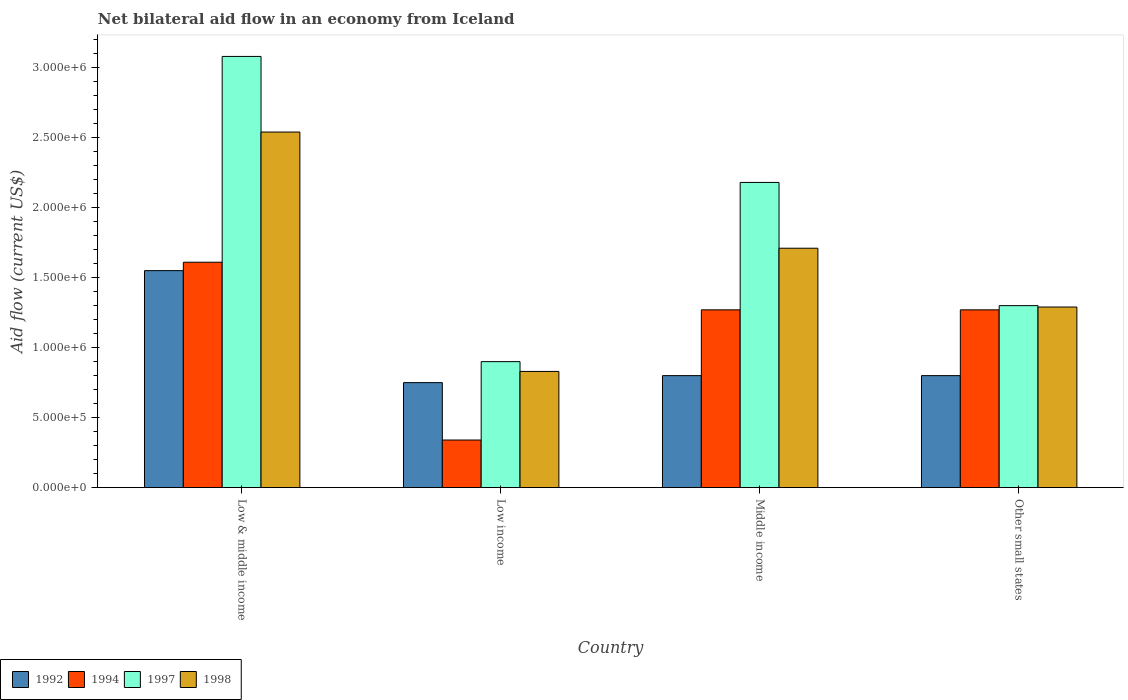How many different coloured bars are there?
Ensure brevity in your answer.  4. How many groups of bars are there?
Provide a short and direct response. 4. Are the number of bars per tick equal to the number of legend labels?
Provide a succinct answer. Yes. How many bars are there on the 1st tick from the left?
Keep it short and to the point. 4. What is the label of the 4th group of bars from the left?
Keep it short and to the point. Other small states. In how many cases, is the number of bars for a given country not equal to the number of legend labels?
Keep it short and to the point. 0. What is the net bilateral aid flow in 1998 in Low & middle income?
Give a very brief answer. 2.54e+06. Across all countries, what is the maximum net bilateral aid flow in 1994?
Offer a very short reply. 1.61e+06. Across all countries, what is the minimum net bilateral aid flow in 1997?
Offer a terse response. 9.00e+05. In which country was the net bilateral aid flow in 1997 maximum?
Provide a succinct answer. Low & middle income. In which country was the net bilateral aid flow in 1997 minimum?
Your answer should be very brief. Low income. What is the total net bilateral aid flow in 1997 in the graph?
Your answer should be very brief. 7.46e+06. What is the difference between the net bilateral aid flow in 1994 in Low & middle income and the net bilateral aid flow in 1997 in Middle income?
Offer a terse response. -5.70e+05. What is the average net bilateral aid flow in 1997 per country?
Your response must be concise. 1.86e+06. What is the difference between the net bilateral aid flow of/in 1994 and net bilateral aid flow of/in 1992 in Low income?
Your response must be concise. -4.10e+05. In how many countries, is the net bilateral aid flow in 1994 greater than 1000000 US$?
Your answer should be very brief. 3. What is the ratio of the net bilateral aid flow in 1997 in Low & middle income to that in Other small states?
Give a very brief answer. 2.37. What is the difference between the highest and the second highest net bilateral aid flow in 1997?
Offer a very short reply. 1.78e+06. What is the difference between the highest and the lowest net bilateral aid flow in 1997?
Offer a terse response. 2.18e+06. In how many countries, is the net bilateral aid flow in 1997 greater than the average net bilateral aid flow in 1997 taken over all countries?
Offer a terse response. 2. Is the sum of the net bilateral aid flow in 1997 in Low & middle income and Low income greater than the maximum net bilateral aid flow in 1992 across all countries?
Your answer should be very brief. Yes. Is it the case that in every country, the sum of the net bilateral aid flow in 1992 and net bilateral aid flow in 1994 is greater than the sum of net bilateral aid flow in 1997 and net bilateral aid flow in 1998?
Make the answer very short. No. What does the 4th bar from the left in Middle income represents?
Ensure brevity in your answer.  1998. Is it the case that in every country, the sum of the net bilateral aid flow in 1997 and net bilateral aid flow in 1992 is greater than the net bilateral aid flow in 1998?
Make the answer very short. Yes. What is the difference between two consecutive major ticks on the Y-axis?
Give a very brief answer. 5.00e+05. How are the legend labels stacked?
Make the answer very short. Horizontal. What is the title of the graph?
Keep it short and to the point. Net bilateral aid flow in an economy from Iceland. What is the label or title of the X-axis?
Provide a succinct answer. Country. What is the Aid flow (current US$) of 1992 in Low & middle income?
Give a very brief answer. 1.55e+06. What is the Aid flow (current US$) in 1994 in Low & middle income?
Offer a terse response. 1.61e+06. What is the Aid flow (current US$) in 1997 in Low & middle income?
Make the answer very short. 3.08e+06. What is the Aid flow (current US$) in 1998 in Low & middle income?
Your answer should be very brief. 2.54e+06. What is the Aid flow (current US$) of 1992 in Low income?
Keep it short and to the point. 7.50e+05. What is the Aid flow (current US$) of 1998 in Low income?
Provide a short and direct response. 8.30e+05. What is the Aid flow (current US$) of 1994 in Middle income?
Offer a terse response. 1.27e+06. What is the Aid flow (current US$) of 1997 in Middle income?
Your answer should be compact. 2.18e+06. What is the Aid flow (current US$) in 1998 in Middle income?
Provide a short and direct response. 1.71e+06. What is the Aid flow (current US$) of 1992 in Other small states?
Keep it short and to the point. 8.00e+05. What is the Aid flow (current US$) in 1994 in Other small states?
Offer a terse response. 1.27e+06. What is the Aid flow (current US$) in 1997 in Other small states?
Offer a very short reply. 1.30e+06. What is the Aid flow (current US$) of 1998 in Other small states?
Make the answer very short. 1.29e+06. Across all countries, what is the maximum Aid flow (current US$) in 1992?
Make the answer very short. 1.55e+06. Across all countries, what is the maximum Aid flow (current US$) of 1994?
Ensure brevity in your answer.  1.61e+06. Across all countries, what is the maximum Aid flow (current US$) in 1997?
Keep it short and to the point. 3.08e+06. Across all countries, what is the maximum Aid flow (current US$) in 1998?
Your answer should be very brief. 2.54e+06. Across all countries, what is the minimum Aid flow (current US$) in 1992?
Offer a terse response. 7.50e+05. Across all countries, what is the minimum Aid flow (current US$) in 1994?
Provide a short and direct response. 3.40e+05. Across all countries, what is the minimum Aid flow (current US$) in 1998?
Provide a succinct answer. 8.30e+05. What is the total Aid flow (current US$) in 1992 in the graph?
Ensure brevity in your answer.  3.90e+06. What is the total Aid flow (current US$) in 1994 in the graph?
Your answer should be very brief. 4.49e+06. What is the total Aid flow (current US$) in 1997 in the graph?
Your answer should be very brief. 7.46e+06. What is the total Aid flow (current US$) of 1998 in the graph?
Make the answer very short. 6.37e+06. What is the difference between the Aid flow (current US$) in 1992 in Low & middle income and that in Low income?
Keep it short and to the point. 8.00e+05. What is the difference between the Aid flow (current US$) in 1994 in Low & middle income and that in Low income?
Your answer should be compact. 1.27e+06. What is the difference between the Aid flow (current US$) in 1997 in Low & middle income and that in Low income?
Make the answer very short. 2.18e+06. What is the difference between the Aid flow (current US$) in 1998 in Low & middle income and that in Low income?
Ensure brevity in your answer.  1.71e+06. What is the difference between the Aid flow (current US$) of 1992 in Low & middle income and that in Middle income?
Your response must be concise. 7.50e+05. What is the difference between the Aid flow (current US$) in 1997 in Low & middle income and that in Middle income?
Ensure brevity in your answer.  9.00e+05. What is the difference between the Aid flow (current US$) in 1998 in Low & middle income and that in Middle income?
Give a very brief answer. 8.30e+05. What is the difference between the Aid flow (current US$) of 1992 in Low & middle income and that in Other small states?
Offer a terse response. 7.50e+05. What is the difference between the Aid flow (current US$) in 1994 in Low & middle income and that in Other small states?
Ensure brevity in your answer.  3.40e+05. What is the difference between the Aid flow (current US$) of 1997 in Low & middle income and that in Other small states?
Provide a short and direct response. 1.78e+06. What is the difference between the Aid flow (current US$) of 1998 in Low & middle income and that in Other small states?
Provide a succinct answer. 1.25e+06. What is the difference between the Aid flow (current US$) in 1994 in Low income and that in Middle income?
Provide a succinct answer. -9.30e+05. What is the difference between the Aid flow (current US$) in 1997 in Low income and that in Middle income?
Ensure brevity in your answer.  -1.28e+06. What is the difference between the Aid flow (current US$) of 1998 in Low income and that in Middle income?
Make the answer very short. -8.80e+05. What is the difference between the Aid flow (current US$) in 1994 in Low income and that in Other small states?
Provide a short and direct response. -9.30e+05. What is the difference between the Aid flow (current US$) in 1997 in Low income and that in Other small states?
Offer a very short reply. -4.00e+05. What is the difference between the Aid flow (current US$) of 1998 in Low income and that in Other small states?
Provide a succinct answer. -4.60e+05. What is the difference between the Aid flow (current US$) in 1994 in Middle income and that in Other small states?
Your response must be concise. 0. What is the difference between the Aid flow (current US$) in 1997 in Middle income and that in Other small states?
Your answer should be very brief. 8.80e+05. What is the difference between the Aid flow (current US$) of 1998 in Middle income and that in Other small states?
Your answer should be very brief. 4.20e+05. What is the difference between the Aid flow (current US$) of 1992 in Low & middle income and the Aid flow (current US$) of 1994 in Low income?
Ensure brevity in your answer.  1.21e+06. What is the difference between the Aid flow (current US$) of 1992 in Low & middle income and the Aid flow (current US$) of 1997 in Low income?
Keep it short and to the point. 6.50e+05. What is the difference between the Aid flow (current US$) in 1992 in Low & middle income and the Aid flow (current US$) in 1998 in Low income?
Ensure brevity in your answer.  7.20e+05. What is the difference between the Aid flow (current US$) of 1994 in Low & middle income and the Aid flow (current US$) of 1997 in Low income?
Your answer should be compact. 7.10e+05. What is the difference between the Aid flow (current US$) of 1994 in Low & middle income and the Aid flow (current US$) of 1998 in Low income?
Provide a short and direct response. 7.80e+05. What is the difference between the Aid flow (current US$) of 1997 in Low & middle income and the Aid flow (current US$) of 1998 in Low income?
Provide a short and direct response. 2.25e+06. What is the difference between the Aid flow (current US$) of 1992 in Low & middle income and the Aid flow (current US$) of 1994 in Middle income?
Your response must be concise. 2.80e+05. What is the difference between the Aid flow (current US$) in 1992 in Low & middle income and the Aid flow (current US$) in 1997 in Middle income?
Your response must be concise. -6.30e+05. What is the difference between the Aid flow (current US$) of 1992 in Low & middle income and the Aid flow (current US$) of 1998 in Middle income?
Offer a terse response. -1.60e+05. What is the difference between the Aid flow (current US$) of 1994 in Low & middle income and the Aid flow (current US$) of 1997 in Middle income?
Keep it short and to the point. -5.70e+05. What is the difference between the Aid flow (current US$) in 1997 in Low & middle income and the Aid flow (current US$) in 1998 in Middle income?
Your answer should be compact. 1.37e+06. What is the difference between the Aid flow (current US$) of 1992 in Low & middle income and the Aid flow (current US$) of 1994 in Other small states?
Provide a succinct answer. 2.80e+05. What is the difference between the Aid flow (current US$) in 1992 in Low & middle income and the Aid flow (current US$) in 1998 in Other small states?
Offer a very short reply. 2.60e+05. What is the difference between the Aid flow (current US$) in 1997 in Low & middle income and the Aid flow (current US$) in 1998 in Other small states?
Provide a succinct answer. 1.79e+06. What is the difference between the Aid flow (current US$) in 1992 in Low income and the Aid flow (current US$) in 1994 in Middle income?
Give a very brief answer. -5.20e+05. What is the difference between the Aid flow (current US$) in 1992 in Low income and the Aid flow (current US$) in 1997 in Middle income?
Your answer should be compact. -1.43e+06. What is the difference between the Aid flow (current US$) in 1992 in Low income and the Aid flow (current US$) in 1998 in Middle income?
Offer a terse response. -9.60e+05. What is the difference between the Aid flow (current US$) of 1994 in Low income and the Aid flow (current US$) of 1997 in Middle income?
Your response must be concise. -1.84e+06. What is the difference between the Aid flow (current US$) of 1994 in Low income and the Aid flow (current US$) of 1998 in Middle income?
Make the answer very short. -1.37e+06. What is the difference between the Aid flow (current US$) in 1997 in Low income and the Aid flow (current US$) in 1998 in Middle income?
Your answer should be very brief. -8.10e+05. What is the difference between the Aid flow (current US$) in 1992 in Low income and the Aid flow (current US$) in 1994 in Other small states?
Your response must be concise. -5.20e+05. What is the difference between the Aid flow (current US$) in 1992 in Low income and the Aid flow (current US$) in 1997 in Other small states?
Provide a succinct answer. -5.50e+05. What is the difference between the Aid flow (current US$) of 1992 in Low income and the Aid flow (current US$) of 1998 in Other small states?
Your answer should be compact. -5.40e+05. What is the difference between the Aid flow (current US$) of 1994 in Low income and the Aid flow (current US$) of 1997 in Other small states?
Provide a succinct answer. -9.60e+05. What is the difference between the Aid flow (current US$) of 1994 in Low income and the Aid flow (current US$) of 1998 in Other small states?
Your response must be concise. -9.50e+05. What is the difference between the Aid flow (current US$) of 1997 in Low income and the Aid flow (current US$) of 1998 in Other small states?
Give a very brief answer. -3.90e+05. What is the difference between the Aid flow (current US$) of 1992 in Middle income and the Aid flow (current US$) of 1994 in Other small states?
Offer a very short reply. -4.70e+05. What is the difference between the Aid flow (current US$) in 1992 in Middle income and the Aid flow (current US$) in 1997 in Other small states?
Keep it short and to the point. -5.00e+05. What is the difference between the Aid flow (current US$) of 1992 in Middle income and the Aid flow (current US$) of 1998 in Other small states?
Ensure brevity in your answer.  -4.90e+05. What is the difference between the Aid flow (current US$) in 1994 in Middle income and the Aid flow (current US$) in 1997 in Other small states?
Give a very brief answer. -3.00e+04. What is the difference between the Aid flow (current US$) in 1997 in Middle income and the Aid flow (current US$) in 1998 in Other small states?
Ensure brevity in your answer.  8.90e+05. What is the average Aid flow (current US$) of 1992 per country?
Your answer should be compact. 9.75e+05. What is the average Aid flow (current US$) of 1994 per country?
Ensure brevity in your answer.  1.12e+06. What is the average Aid flow (current US$) of 1997 per country?
Offer a very short reply. 1.86e+06. What is the average Aid flow (current US$) in 1998 per country?
Offer a very short reply. 1.59e+06. What is the difference between the Aid flow (current US$) of 1992 and Aid flow (current US$) of 1997 in Low & middle income?
Your answer should be very brief. -1.53e+06. What is the difference between the Aid flow (current US$) of 1992 and Aid flow (current US$) of 1998 in Low & middle income?
Your response must be concise. -9.90e+05. What is the difference between the Aid flow (current US$) of 1994 and Aid flow (current US$) of 1997 in Low & middle income?
Make the answer very short. -1.47e+06. What is the difference between the Aid flow (current US$) in 1994 and Aid flow (current US$) in 1998 in Low & middle income?
Provide a succinct answer. -9.30e+05. What is the difference between the Aid flow (current US$) of 1997 and Aid flow (current US$) of 1998 in Low & middle income?
Your response must be concise. 5.40e+05. What is the difference between the Aid flow (current US$) in 1992 and Aid flow (current US$) in 1994 in Low income?
Offer a very short reply. 4.10e+05. What is the difference between the Aid flow (current US$) in 1992 and Aid flow (current US$) in 1998 in Low income?
Ensure brevity in your answer.  -8.00e+04. What is the difference between the Aid flow (current US$) of 1994 and Aid flow (current US$) of 1997 in Low income?
Offer a terse response. -5.60e+05. What is the difference between the Aid flow (current US$) of 1994 and Aid flow (current US$) of 1998 in Low income?
Provide a short and direct response. -4.90e+05. What is the difference between the Aid flow (current US$) in 1992 and Aid flow (current US$) in 1994 in Middle income?
Your answer should be compact. -4.70e+05. What is the difference between the Aid flow (current US$) in 1992 and Aid flow (current US$) in 1997 in Middle income?
Your response must be concise. -1.38e+06. What is the difference between the Aid flow (current US$) of 1992 and Aid flow (current US$) of 1998 in Middle income?
Offer a terse response. -9.10e+05. What is the difference between the Aid flow (current US$) of 1994 and Aid flow (current US$) of 1997 in Middle income?
Offer a terse response. -9.10e+05. What is the difference between the Aid flow (current US$) of 1994 and Aid flow (current US$) of 1998 in Middle income?
Offer a terse response. -4.40e+05. What is the difference between the Aid flow (current US$) of 1997 and Aid flow (current US$) of 1998 in Middle income?
Offer a very short reply. 4.70e+05. What is the difference between the Aid flow (current US$) of 1992 and Aid flow (current US$) of 1994 in Other small states?
Your answer should be very brief. -4.70e+05. What is the difference between the Aid flow (current US$) of 1992 and Aid flow (current US$) of 1997 in Other small states?
Your answer should be compact. -5.00e+05. What is the difference between the Aid flow (current US$) of 1992 and Aid flow (current US$) of 1998 in Other small states?
Your response must be concise. -4.90e+05. What is the difference between the Aid flow (current US$) in 1994 and Aid flow (current US$) in 1997 in Other small states?
Provide a succinct answer. -3.00e+04. What is the difference between the Aid flow (current US$) in 1997 and Aid flow (current US$) in 1998 in Other small states?
Offer a terse response. 10000. What is the ratio of the Aid flow (current US$) in 1992 in Low & middle income to that in Low income?
Your answer should be compact. 2.07. What is the ratio of the Aid flow (current US$) in 1994 in Low & middle income to that in Low income?
Make the answer very short. 4.74. What is the ratio of the Aid flow (current US$) in 1997 in Low & middle income to that in Low income?
Give a very brief answer. 3.42. What is the ratio of the Aid flow (current US$) in 1998 in Low & middle income to that in Low income?
Offer a terse response. 3.06. What is the ratio of the Aid flow (current US$) in 1992 in Low & middle income to that in Middle income?
Keep it short and to the point. 1.94. What is the ratio of the Aid flow (current US$) in 1994 in Low & middle income to that in Middle income?
Your answer should be very brief. 1.27. What is the ratio of the Aid flow (current US$) in 1997 in Low & middle income to that in Middle income?
Offer a very short reply. 1.41. What is the ratio of the Aid flow (current US$) of 1998 in Low & middle income to that in Middle income?
Offer a very short reply. 1.49. What is the ratio of the Aid flow (current US$) of 1992 in Low & middle income to that in Other small states?
Give a very brief answer. 1.94. What is the ratio of the Aid flow (current US$) of 1994 in Low & middle income to that in Other small states?
Keep it short and to the point. 1.27. What is the ratio of the Aid flow (current US$) of 1997 in Low & middle income to that in Other small states?
Offer a very short reply. 2.37. What is the ratio of the Aid flow (current US$) of 1998 in Low & middle income to that in Other small states?
Ensure brevity in your answer.  1.97. What is the ratio of the Aid flow (current US$) of 1994 in Low income to that in Middle income?
Provide a succinct answer. 0.27. What is the ratio of the Aid flow (current US$) of 1997 in Low income to that in Middle income?
Keep it short and to the point. 0.41. What is the ratio of the Aid flow (current US$) of 1998 in Low income to that in Middle income?
Your answer should be very brief. 0.49. What is the ratio of the Aid flow (current US$) in 1994 in Low income to that in Other small states?
Provide a short and direct response. 0.27. What is the ratio of the Aid flow (current US$) of 1997 in Low income to that in Other small states?
Give a very brief answer. 0.69. What is the ratio of the Aid flow (current US$) in 1998 in Low income to that in Other small states?
Provide a succinct answer. 0.64. What is the ratio of the Aid flow (current US$) in 1997 in Middle income to that in Other small states?
Ensure brevity in your answer.  1.68. What is the ratio of the Aid flow (current US$) in 1998 in Middle income to that in Other small states?
Offer a very short reply. 1.33. What is the difference between the highest and the second highest Aid flow (current US$) of 1992?
Keep it short and to the point. 7.50e+05. What is the difference between the highest and the second highest Aid flow (current US$) of 1994?
Provide a short and direct response. 3.40e+05. What is the difference between the highest and the second highest Aid flow (current US$) of 1998?
Provide a short and direct response. 8.30e+05. What is the difference between the highest and the lowest Aid flow (current US$) in 1994?
Provide a short and direct response. 1.27e+06. What is the difference between the highest and the lowest Aid flow (current US$) in 1997?
Offer a terse response. 2.18e+06. What is the difference between the highest and the lowest Aid flow (current US$) in 1998?
Offer a terse response. 1.71e+06. 